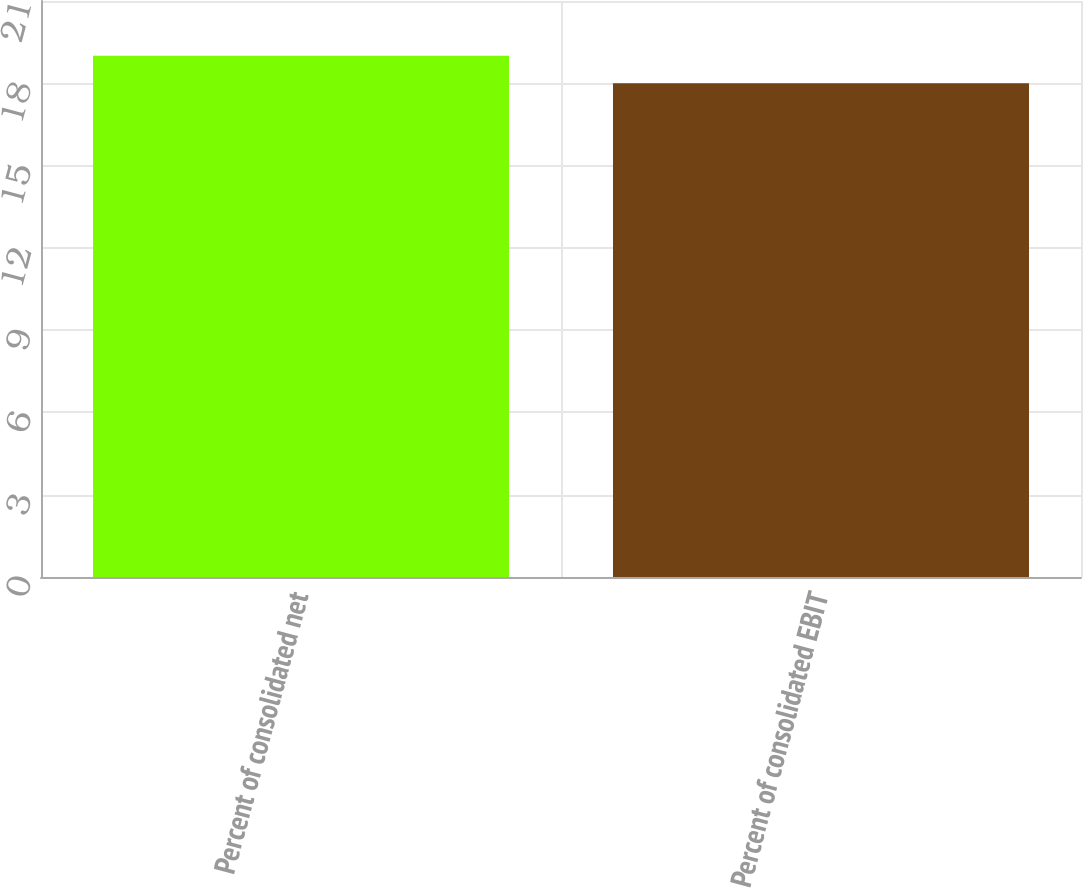Convert chart to OTSL. <chart><loc_0><loc_0><loc_500><loc_500><bar_chart><fcel>Percent of consolidated net<fcel>Percent of consolidated EBIT<nl><fcel>19<fcel>18<nl></chart> 